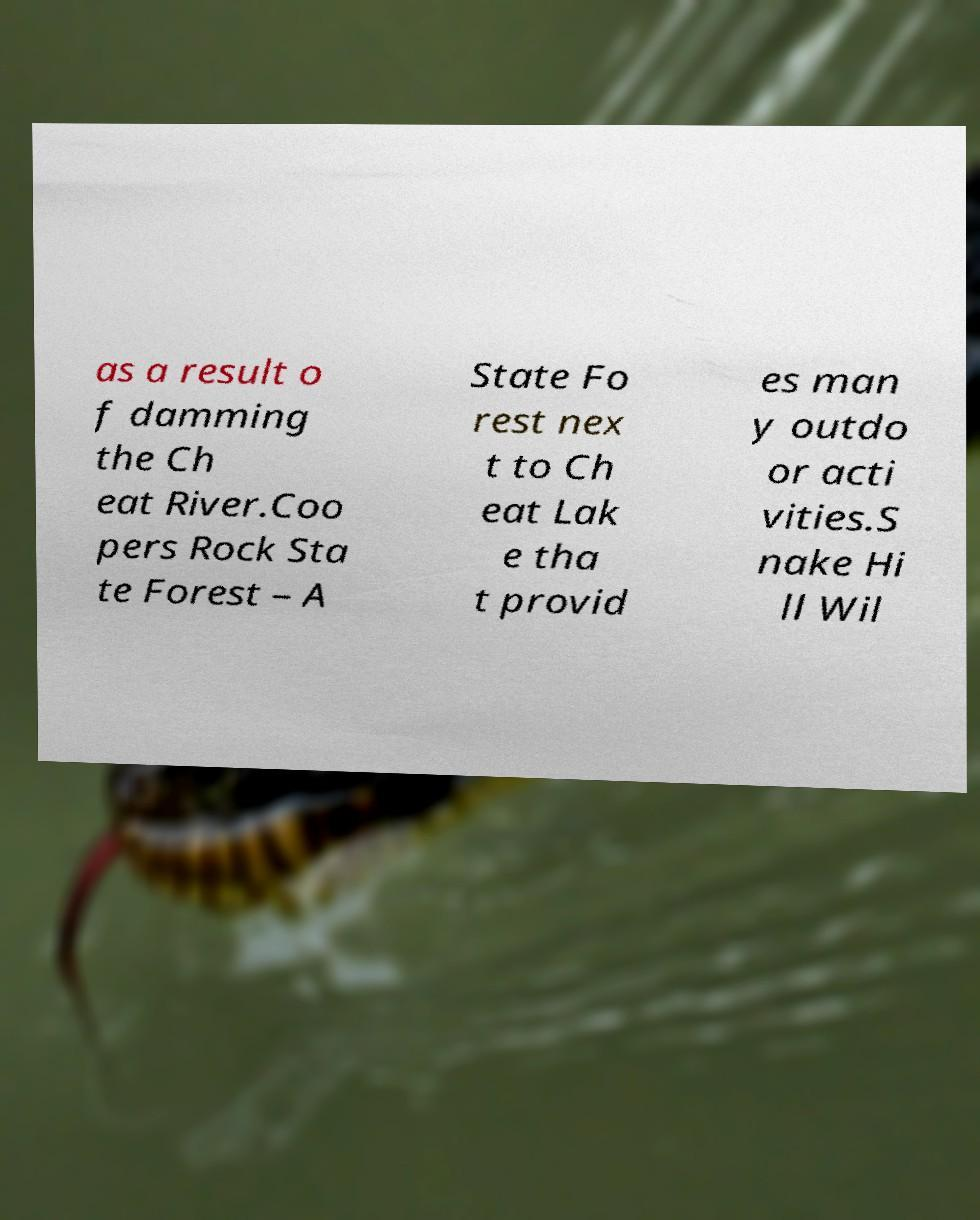Could you assist in decoding the text presented in this image and type it out clearly? as a result o f damming the Ch eat River.Coo pers Rock Sta te Forest – A State Fo rest nex t to Ch eat Lak e tha t provid es man y outdo or acti vities.S nake Hi ll Wil 